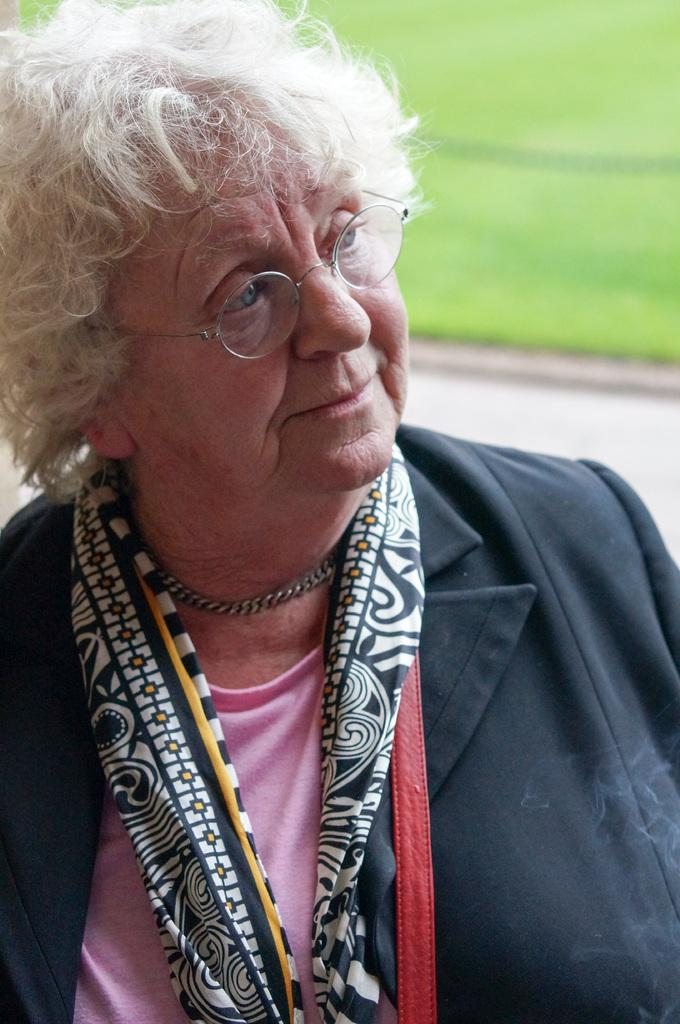Who is present in the image? There is a woman in the image. What is the woman doing in the image? The woman is smiling in the image. What type of terrain is visible in the background of the image? There is grass on the ground in the background of the image. What type of flower is the bear holding in the image? There is no bear or flower present in the image; it features a woman smiling. 